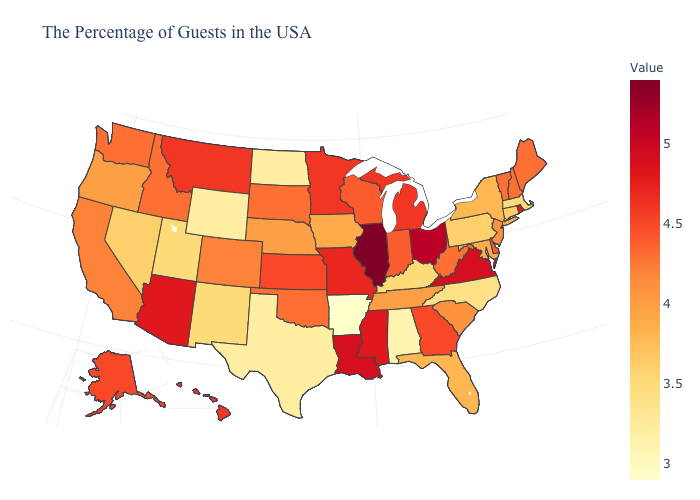Among the states that border New Hampshire , does Massachusetts have the lowest value?
Write a very short answer. Yes. Which states hav the highest value in the Northeast?
Concise answer only. Rhode Island. Which states have the highest value in the USA?
Answer briefly. Illinois. Is the legend a continuous bar?
Concise answer only. Yes. Does the map have missing data?
Concise answer only. No. Does Vermont have the highest value in the Northeast?
Give a very brief answer. No. 